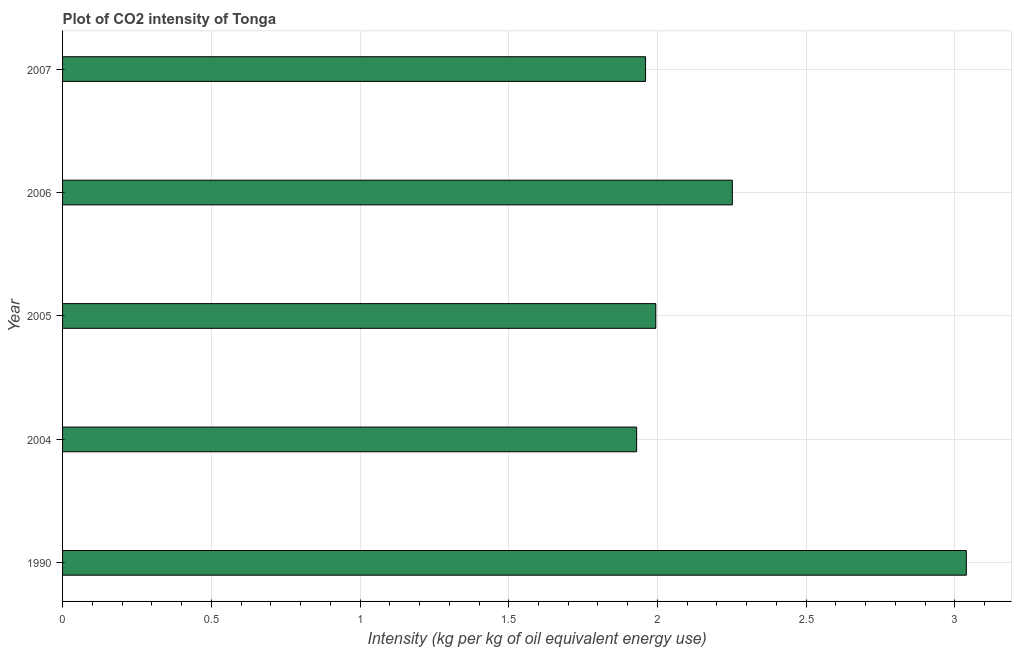What is the title of the graph?
Provide a succinct answer. Plot of CO2 intensity of Tonga. What is the label or title of the X-axis?
Your response must be concise. Intensity (kg per kg of oil equivalent energy use). What is the label or title of the Y-axis?
Provide a succinct answer. Year. What is the co2 intensity in 2006?
Offer a very short reply. 2.25. Across all years, what is the maximum co2 intensity?
Your answer should be very brief. 3.04. Across all years, what is the minimum co2 intensity?
Your answer should be very brief. 1.93. In which year was the co2 intensity minimum?
Ensure brevity in your answer.  2004. What is the sum of the co2 intensity?
Provide a succinct answer. 11.17. What is the difference between the co2 intensity in 2005 and 2007?
Provide a short and direct response. 0.03. What is the average co2 intensity per year?
Provide a short and direct response. 2.23. What is the median co2 intensity?
Ensure brevity in your answer.  1.99. In how many years, is the co2 intensity greater than 2.5 kg?
Give a very brief answer. 1. What is the ratio of the co2 intensity in 2004 to that in 2006?
Make the answer very short. 0.86. Is the co2 intensity in 1990 less than that in 2007?
Keep it short and to the point. No. Is the difference between the co2 intensity in 2005 and 2006 greater than the difference between any two years?
Offer a terse response. No. What is the difference between the highest and the second highest co2 intensity?
Keep it short and to the point. 0.79. What is the difference between the highest and the lowest co2 intensity?
Provide a succinct answer. 1.11. How many bars are there?
Your answer should be compact. 5. Are all the bars in the graph horizontal?
Provide a succinct answer. Yes. Are the values on the major ticks of X-axis written in scientific E-notation?
Your answer should be very brief. No. What is the Intensity (kg per kg of oil equivalent energy use) in 1990?
Provide a succinct answer. 3.04. What is the Intensity (kg per kg of oil equivalent energy use) of 2004?
Make the answer very short. 1.93. What is the Intensity (kg per kg of oil equivalent energy use) of 2005?
Your answer should be compact. 1.99. What is the Intensity (kg per kg of oil equivalent energy use) in 2006?
Offer a very short reply. 2.25. What is the Intensity (kg per kg of oil equivalent energy use) in 2007?
Your answer should be compact. 1.96. What is the difference between the Intensity (kg per kg of oil equivalent energy use) in 1990 and 2004?
Offer a terse response. 1.11. What is the difference between the Intensity (kg per kg of oil equivalent energy use) in 1990 and 2005?
Your response must be concise. 1.04. What is the difference between the Intensity (kg per kg of oil equivalent energy use) in 1990 and 2006?
Your response must be concise. 0.79. What is the difference between the Intensity (kg per kg of oil equivalent energy use) in 1990 and 2007?
Your answer should be very brief. 1.08. What is the difference between the Intensity (kg per kg of oil equivalent energy use) in 2004 and 2005?
Your answer should be compact. -0.06. What is the difference between the Intensity (kg per kg of oil equivalent energy use) in 2004 and 2006?
Your answer should be compact. -0.32. What is the difference between the Intensity (kg per kg of oil equivalent energy use) in 2004 and 2007?
Give a very brief answer. -0.03. What is the difference between the Intensity (kg per kg of oil equivalent energy use) in 2005 and 2006?
Your answer should be very brief. -0.26. What is the difference between the Intensity (kg per kg of oil equivalent energy use) in 2005 and 2007?
Your answer should be compact. 0.03. What is the difference between the Intensity (kg per kg of oil equivalent energy use) in 2006 and 2007?
Provide a succinct answer. 0.29. What is the ratio of the Intensity (kg per kg of oil equivalent energy use) in 1990 to that in 2004?
Your response must be concise. 1.57. What is the ratio of the Intensity (kg per kg of oil equivalent energy use) in 1990 to that in 2005?
Give a very brief answer. 1.52. What is the ratio of the Intensity (kg per kg of oil equivalent energy use) in 1990 to that in 2006?
Keep it short and to the point. 1.35. What is the ratio of the Intensity (kg per kg of oil equivalent energy use) in 1990 to that in 2007?
Give a very brief answer. 1.55. What is the ratio of the Intensity (kg per kg of oil equivalent energy use) in 2004 to that in 2005?
Ensure brevity in your answer.  0.97. What is the ratio of the Intensity (kg per kg of oil equivalent energy use) in 2004 to that in 2006?
Your answer should be compact. 0.86. What is the ratio of the Intensity (kg per kg of oil equivalent energy use) in 2004 to that in 2007?
Make the answer very short. 0.98. What is the ratio of the Intensity (kg per kg of oil equivalent energy use) in 2005 to that in 2006?
Provide a succinct answer. 0.89. What is the ratio of the Intensity (kg per kg of oil equivalent energy use) in 2006 to that in 2007?
Make the answer very short. 1.15. 